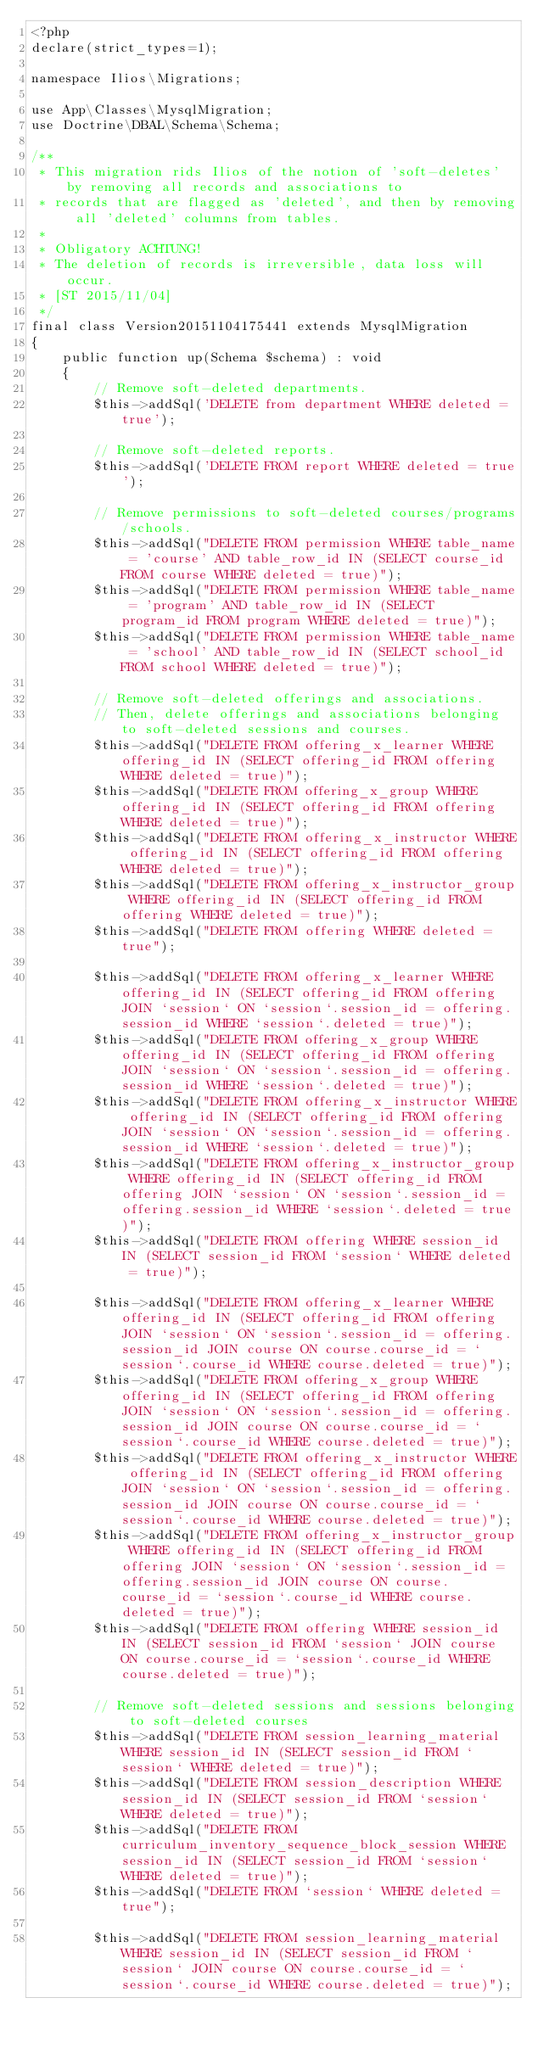Convert code to text. <code><loc_0><loc_0><loc_500><loc_500><_PHP_><?php
declare(strict_types=1);

namespace Ilios\Migrations;

use App\Classes\MysqlMigration;
use Doctrine\DBAL\Schema\Schema;

/**
 * This migration rids Ilios of the notion of 'soft-deletes' by removing all records and associations to
 * records that are flagged as 'deleted', and then by removing all 'deleted' columns from tables.
 *
 * Obligatory ACHTUNG!
 * The deletion of records is irreversible, data loss will occur.
 * [ST 2015/11/04]
 */
final class Version20151104175441 extends MysqlMigration
{
    public function up(Schema $schema) : void
    {
        // Remove soft-deleted departments.
        $this->addSql('DELETE from department WHERE deleted = true');

        // Remove soft-deleted reports.
        $this->addSql('DELETE FROM report WHERE deleted = true');

        // Remove permissions to soft-deleted courses/programs/schools.
        $this->addSql("DELETE FROM permission WHERE table_name = 'course' AND table_row_id IN (SELECT course_id FROM course WHERE deleted = true)");
        $this->addSql("DELETE FROM permission WHERE table_name = 'program' AND table_row_id IN (SELECT program_id FROM program WHERE deleted = true)");
        $this->addSql("DELETE FROM permission WHERE table_name = 'school' AND table_row_id IN (SELECT school_id FROM school WHERE deleted = true)");

        // Remove soft-deleted offerings and associations.
        // Then, delete offerings and associations belonging to soft-deleted sessions and courses.
        $this->addSql("DELETE FROM offering_x_learner WHERE offering_id IN (SELECT offering_id FROM offering WHERE deleted = true)");
        $this->addSql("DELETE FROM offering_x_group WHERE offering_id IN (SELECT offering_id FROM offering WHERE deleted = true)");
        $this->addSql("DELETE FROM offering_x_instructor WHERE offering_id IN (SELECT offering_id FROM offering WHERE deleted = true)");
        $this->addSql("DELETE FROM offering_x_instructor_group WHERE offering_id IN (SELECT offering_id FROM offering WHERE deleted = true)");
        $this->addSql("DELETE FROM offering WHERE deleted = true");

        $this->addSql("DELETE FROM offering_x_learner WHERE offering_id IN (SELECT offering_id FROM offering JOIN `session` ON `session`.session_id = offering.session_id WHERE `session`.deleted = true)");
        $this->addSql("DELETE FROM offering_x_group WHERE offering_id IN (SELECT offering_id FROM offering JOIN `session` ON `session`.session_id = offering.session_id WHERE `session`.deleted = true)");
        $this->addSql("DELETE FROM offering_x_instructor WHERE offering_id IN (SELECT offering_id FROM offering JOIN `session` ON `session`.session_id = offering.session_id WHERE `session`.deleted = true)");
        $this->addSql("DELETE FROM offering_x_instructor_group WHERE offering_id IN (SELECT offering_id FROM offering JOIN `session` ON `session`.session_id = offering.session_id WHERE `session`.deleted = true)");
        $this->addSql("DELETE FROM offering WHERE session_id IN (SELECT session_id FROM `session` WHERE deleted = true)");

        $this->addSql("DELETE FROM offering_x_learner WHERE offering_id IN (SELECT offering_id FROM offering JOIN `session` ON `session`.session_id = offering.session_id JOIN course ON course.course_id = `session`.course_id WHERE course.deleted = true)");
        $this->addSql("DELETE FROM offering_x_group WHERE offering_id IN (SELECT offering_id FROM offering JOIN `session` ON `session`.session_id = offering.session_id JOIN course ON course.course_id = `session`.course_id WHERE course.deleted = true)");
        $this->addSql("DELETE FROM offering_x_instructor WHERE offering_id IN (SELECT offering_id FROM offering JOIN `session` ON `session`.session_id = offering.session_id JOIN course ON course.course_id = `session`.course_id WHERE course.deleted = true)");
        $this->addSql("DELETE FROM offering_x_instructor_group WHERE offering_id IN (SELECT offering_id FROM offering JOIN `session` ON `session`.session_id = offering.session_id JOIN course ON course.course_id = `session`.course_id WHERE course.deleted = true)");
        $this->addSql("DELETE FROM offering WHERE session_id IN (SELECT session_id FROM `session` JOIN course ON course.course_id = `session`.course_id WHERE course.deleted = true)");

        // Remove soft-deleted sessions and sessions belonging to soft-deleted courses
        $this->addSql("DELETE FROM session_learning_material WHERE session_id IN (SELECT session_id FROM `session` WHERE deleted = true)");
        $this->addSql("DELETE FROM session_description WHERE session_id IN (SELECT session_id FROM `session` WHERE deleted = true)");
        $this->addSql("DELETE FROM curriculum_inventory_sequence_block_session WHERE session_id IN (SELECT session_id FROM `session` WHERE deleted = true)");
        $this->addSql("DELETE FROM `session` WHERE deleted = true");

        $this->addSql("DELETE FROM session_learning_material WHERE session_id IN (SELECT session_id FROM `session` JOIN course ON course.course_id = `session`.course_id WHERE course.deleted = true)");</code> 